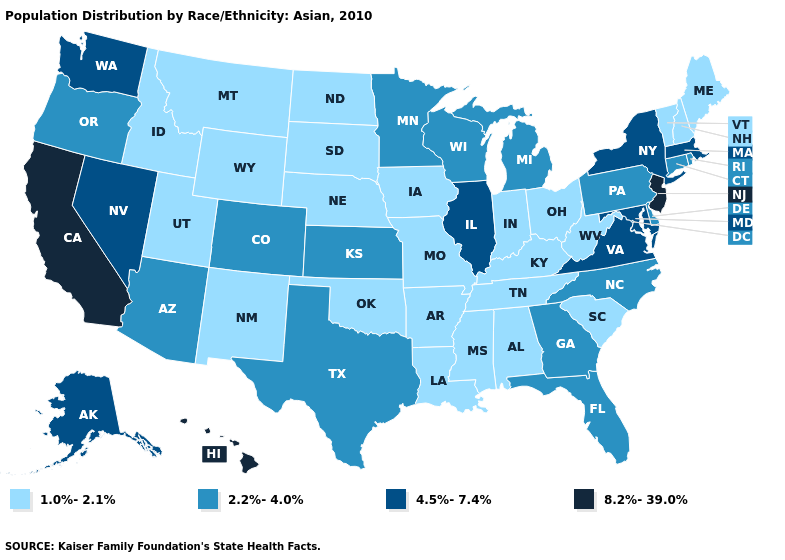Does the first symbol in the legend represent the smallest category?
Give a very brief answer. Yes. What is the lowest value in the USA?
Concise answer only. 1.0%-2.1%. Name the states that have a value in the range 2.2%-4.0%?
Keep it brief. Arizona, Colorado, Connecticut, Delaware, Florida, Georgia, Kansas, Michigan, Minnesota, North Carolina, Oregon, Pennsylvania, Rhode Island, Texas, Wisconsin. Among the states that border Rhode Island , which have the highest value?
Keep it brief. Massachusetts. What is the highest value in the USA?
Answer briefly. 8.2%-39.0%. Which states hav the highest value in the MidWest?
Short answer required. Illinois. Name the states that have a value in the range 2.2%-4.0%?
Answer briefly. Arizona, Colorado, Connecticut, Delaware, Florida, Georgia, Kansas, Michigan, Minnesota, North Carolina, Oregon, Pennsylvania, Rhode Island, Texas, Wisconsin. Does Nebraska have the lowest value in the USA?
Be succinct. Yes. What is the value of North Dakota?
Answer briefly. 1.0%-2.1%. Does North Carolina have the lowest value in the South?
Keep it brief. No. Name the states that have a value in the range 2.2%-4.0%?
Answer briefly. Arizona, Colorado, Connecticut, Delaware, Florida, Georgia, Kansas, Michigan, Minnesota, North Carolina, Oregon, Pennsylvania, Rhode Island, Texas, Wisconsin. Which states hav the highest value in the MidWest?
Write a very short answer. Illinois. Among the states that border Washington , which have the lowest value?
Keep it brief. Idaho. What is the value of Utah?
Short answer required. 1.0%-2.1%. Name the states that have a value in the range 1.0%-2.1%?
Concise answer only. Alabama, Arkansas, Idaho, Indiana, Iowa, Kentucky, Louisiana, Maine, Mississippi, Missouri, Montana, Nebraska, New Hampshire, New Mexico, North Dakota, Ohio, Oklahoma, South Carolina, South Dakota, Tennessee, Utah, Vermont, West Virginia, Wyoming. 